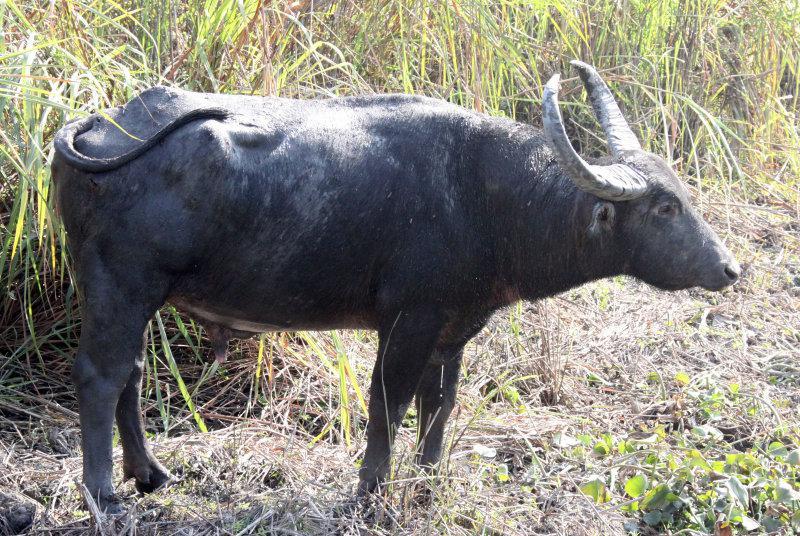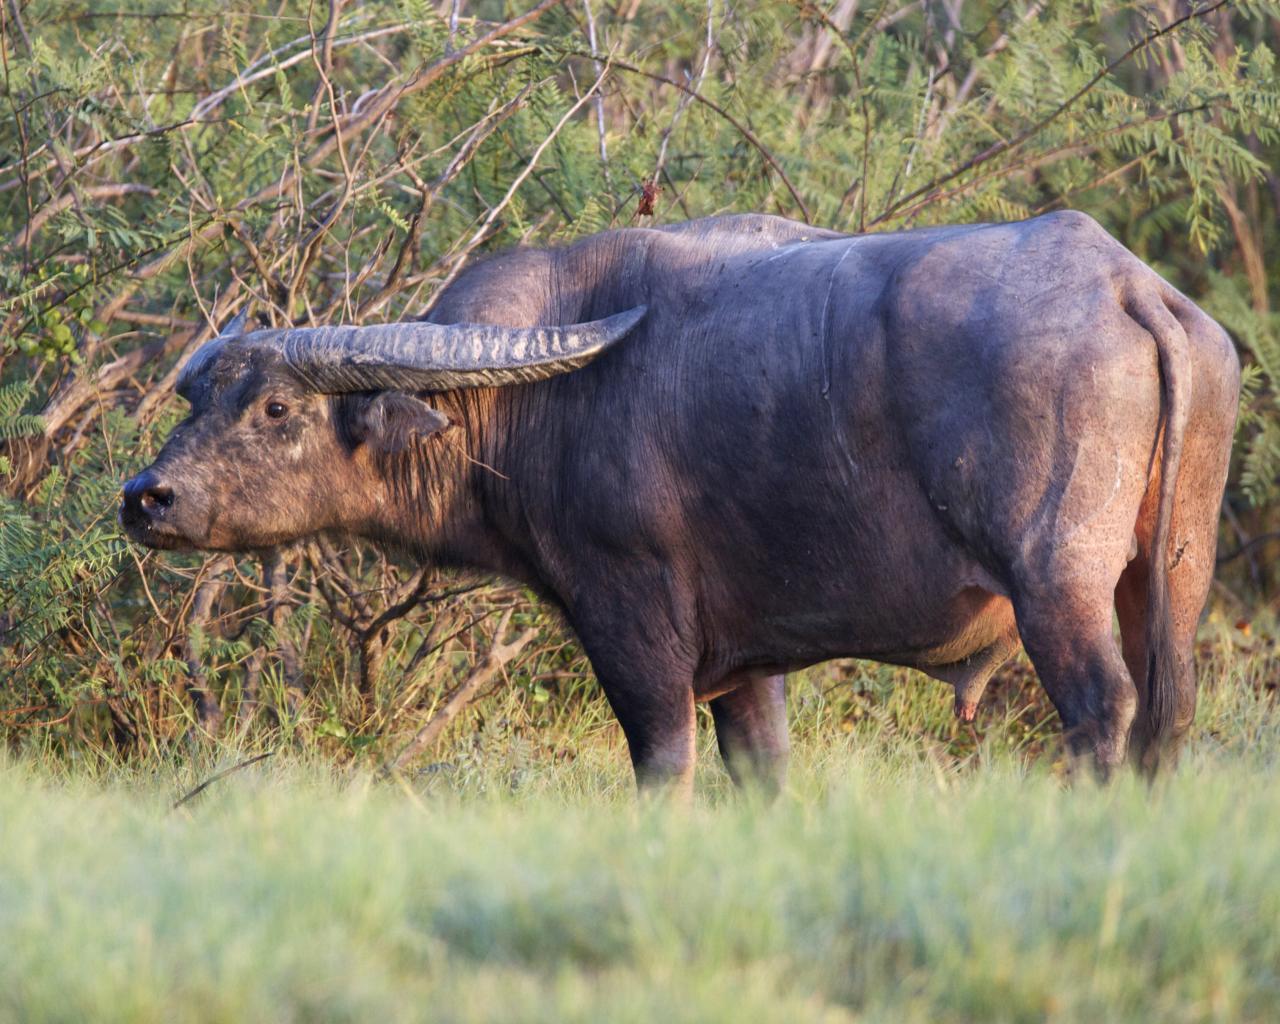The first image is the image on the left, the second image is the image on the right. For the images displayed, is the sentence "A water buffalo is standing on a body of water." factually correct? Answer yes or no. No. The first image is the image on the left, the second image is the image on the right. Analyze the images presented: Is the assertion "An image shows exactly one water buffalo, which is standing in muddy water." valid? Answer yes or no. No. 